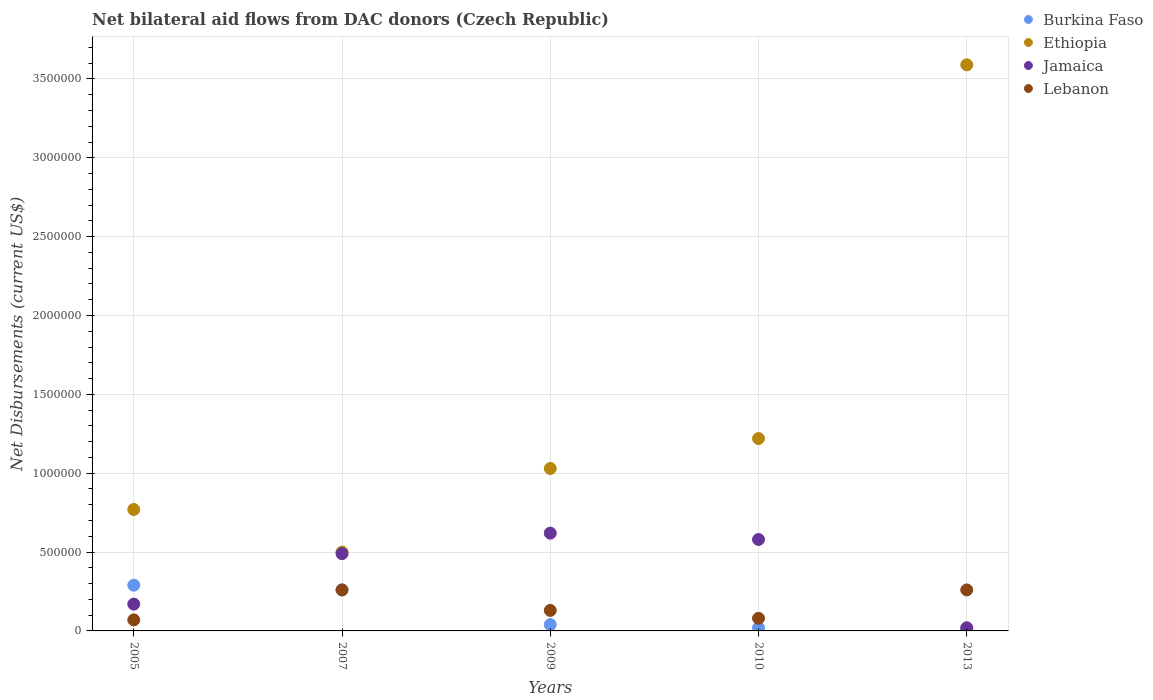What is the net bilateral aid flows in Ethiopia in 2010?
Offer a terse response. 1.22e+06. Across all years, what is the maximum net bilateral aid flows in Lebanon?
Give a very brief answer. 2.60e+05. In which year was the net bilateral aid flows in Lebanon maximum?
Keep it short and to the point. 2007. In which year was the net bilateral aid flows in Lebanon minimum?
Offer a very short reply. 2005. What is the total net bilateral aid flows in Ethiopia in the graph?
Your response must be concise. 7.11e+06. What is the difference between the net bilateral aid flows in Ethiopia in 2010 and that in 2013?
Give a very brief answer. -2.37e+06. What is the average net bilateral aid flows in Jamaica per year?
Keep it short and to the point. 3.76e+05. What is the ratio of the net bilateral aid flows in Jamaica in 2005 to that in 2009?
Your response must be concise. 0.27. Is the net bilateral aid flows in Lebanon in 2007 less than that in 2009?
Give a very brief answer. No. What is the difference between the highest and the second highest net bilateral aid flows in Lebanon?
Offer a terse response. 0. What is the difference between the highest and the lowest net bilateral aid flows in Burkina Faso?
Provide a short and direct response. 2.80e+05. In how many years, is the net bilateral aid flows in Burkina Faso greater than the average net bilateral aid flows in Burkina Faso taken over all years?
Offer a terse response. 2. Is the sum of the net bilateral aid flows in Jamaica in 2009 and 2010 greater than the maximum net bilateral aid flows in Ethiopia across all years?
Give a very brief answer. No. Is the net bilateral aid flows in Ethiopia strictly greater than the net bilateral aid flows in Burkina Faso over the years?
Keep it short and to the point. Yes. How many dotlines are there?
Provide a succinct answer. 4. Are the values on the major ticks of Y-axis written in scientific E-notation?
Provide a short and direct response. No. Does the graph contain any zero values?
Offer a terse response. No. What is the title of the graph?
Keep it short and to the point. Net bilateral aid flows from DAC donors (Czech Republic). Does "Greenland" appear as one of the legend labels in the graph?
Your response must be concise. No. What is the label or title of the Y-axis?
Ensure brevity in your answer.  Net Disbursements (current US$). What is the Net Disbursements (current US$) of Ethiopia in 2005?
Your response must be concise. 7.70e+05. What is the Net Disbursements (current US$) of Lebanon in 2005?
Your answer should be very brief. 7.00e+04. What is the Net Disbursements (current US$) of Burkina Faso in 2009?
Offer a terse response. 4.00e+04. What is the Net Disbursements (current US$) in Ethiopia in 2009?
Your response must be concise. 1.03e+06. What is the Net Disbursements (current US$) of Jamaica in 2009?
Provide a succinct answer. 6.20e+05. What is the Net Disbursements (current US$) in Lebanon in 2009?
Ensure brevity in your answer.  1.30e+05. What is the Net Disbursements (current US$) of Ethiopia in 2010?
Ensure brevity in your answer.  1.22e+06. What is the Net Disbursements (current US$) in Jamaica in 2010?
Ensure brevity in your answer.  5.80e+05. What is the Net Disbursements (current US$) of Lebanon in 2010?
Your answer should be compact. 8.00e+04. What is the Net Disbursements (current US$) of Ethiopia in 2013?
Your response must be concise. 3.59e+06. What is the Net Disbursements (current US$) of Jamaica in 2013?
Offer a very short reply. 2.00e+04. Across all years, what is the maximum Net Disbursements (current US$) of Ethiopia?
Make the answer very short. 3.59e+06. Across all years, what is the maximum Net Disbursements (current US$) of Jamaica?
Your answer should be compact. 6.20e+05. Across all years, what is the maximum Net Disbursements (current US$) in Lebanon?
Give a very brief answer. 2.60e+05. What is the total Net Disbursements (current US$) of Burkina Faso in the graph?
Your response must be concise. 6.20e+05. What is the total Net Disbursements (current US$) in Ethiopia in the graph?
Offer a terse response. 7.11e+06. What is the total Net Disbursements (current US$) in Jamaica in the graph?
Keep it short and to the point. 1.88e+06. What is the total Net Disbursements (current US$) of Lebanon in the graph?
Your response must be concise. 8.00e+05. What is the difference between the Net Disbursements (current US$) of Burkina Faso in 2005 and that in 2007?
Ensure brevity in your answer.  3.00e+04. What is the difference between the Net Disbursements (current US$) of Ethiopia in 2005 and that in 2007?
Ensure brevity in your answer.  2.70e+05. What is the difference between the Net Disbursements (current US$) of Jamaica in 2005 and that in 2007?
Ensure brevity in your answer.  -3.20e+05. What is the difference between the Net Disbursements (current US$) in Lebanon in 2005 and that in 2007?
Give a very brief answer. -1.90e+05. What is the difference between the Net Disbursements (current US$) in Burkina Faso in 2005 and that in 2009?
Your answer should be very brief. 2.50e+05. What is the difference between the Net Disbursements (current US$) of Jamaica in 2005 and that in 2009?
Give a very brief answer. -4.50e+05. What is the difference between the Net Disbursements (current US$) of Ethiopia in 2005 and that in 2010?
Your answer should be compact. -4.50e+05. What is the difference between the Net Disbursements (current US$) in Jamaica in 2005 and that in 2010?
Make the answer very short. -4.10e+05. What is the difference between the Net Disbursements (current US$) of Burkina Faso in 2005 and that in 2013?
Ensure brevity in your answer.  2.80e+05. What is the difference between the Net Disbursements (current US$) of Ethiopia in 2005 and that in 2013?
Your answer should be compact. -2.82e+06. What is the difference between the Net Disbursements (current US$) of Jamaica in 2005 and that in 2013?
Provide a succinct answer. 1.50e+05. What is the difference between the Net Disbursements (current US$) in Lebanon in 2005 and that in 2013?
Offer a very short reply. -1.90e+05. What is the difference between the Net Disbursements (current US$) in Ethiopia in 2007 and that in 2009?
Give a very brief answer. -5.30e+05. What is the difference between the Net Disbursements (current US$) in Lebanon in 2007 and that in 2009?
Offer a very short reply. 1.30e+05. What is the difference between the Net Disbursements (current US$) in Ethiopia in 2007 and that in 2010?
Provide a succinct answer. -7.20e+05. What is the difference between the Net Disbursements (current US$) of Jamaica in 2007 and that in 2010?
Give a very brief answer. -9.00e+04. What is the difference between the Net Disbursements (current US$) in Burkina Faso in 2007 and that in 2013?
Give a very brief answer. 2.50e+05. What is the difference between the Net Disbursements (current US$) of Ethiopia in 2007 and that in 2013?
Give a very brief answer. -3.09e+06. What is the difference between the Net Disbursements (current US$) of Lebanon in 2007 and that in 2013?
Keep it short and to the point. 0. What is the difference between the Net Disbursements (current US$) of Lebanon in 2009 and that in 2010?
Offer a terse response. 5.00e+04. What is the difference between the Net Disbursements (current US$) in Burkina Faso in 2009 and that in 2013?
Make the answer very short. 3.00e+04. What is the difference between the Net Disbursements (current US$) in Ethiopia in 2009 and that in 2013?
Your response must be concise. -2.56e+06. What is the difference between the Net Disbursements (current US$) of Jamaica in 2009 and that in 2013?
Offer a very short reply. 6.00e+05. What is the difference between the Net Disbursements (current US$) in Ethiopia in 2010 and that in 2013?
Ensure brevity in your answer.  -2.37e+06. What is the difference between the Net Disbursements (current US$) in Jamaica in 2010 and that in 2013?
Provide a short and direct response. 5.60e+05. What is the difference between the Net Disbursements (current US$) of Lebanon in 2010 and that in 2013?
Make the answer very short. -1.80e+05. What is the difference between the Net Disbursements (current US$) of Burkina Faso in 2005 and the Net Disbursements (current US$) of Jamaica in 2007?
Provide a short and direct response. -2.00e+05. What is the difference between the Net Disbursements (current US$) of Burkina Faso in 2005 and the Net Disbursements (current US$) of Lebanon in 2007?
Your answer should be compact. 3.00e+04. What is the difference between the Net Disbursements (current US$) in Ethiopia in 2005 and the Net Disbursements (current US$) in Jamaica in 2007?
Keep it short and to the point. 2.80e+05. What is the difference between the Net Disbursements (current US$) of Ethiopia in 2005 and the Net Disbursements (current US$) of Lebanon in 2007?
Ensure brevity in your answer.  5.10e+05. What is the difference between the Net Disbursements (current US$) of Jamaica in 2005 and the Net Disbursements (current US$) of Lebanon in 2007?
Provide a short and direct response. -9.00e+04. What is the difference between the Net Disbursements (current US$) in Burkina Faso in 2005 and the Net Disbursements (current US$) in Ethiopia in 2009?
Your answer should be compact. -7.40e+05. What is the difference between the Net Disbursements (current US$) of Burkina Faso in 2005 and the Net Disbursements (current US$) of Jamaica in 2009?
Keep it short and to the point. -3.30e+05. What is the difference between the Net Disbursements (current US$) of Ethiopia in 2005 and the Net Disbursements (current US$) of Jamaica in 2009?
Offer a very short reply. 1.50e+05. What is the difference between the Net Disbursements (current US$) in Ethiopia in 2005 and the Net Disbursements (current US$) in Lebanon in 2009?
Keep it short and to the point. 6.40e+05. What is the difference between the Net Disbursements (current US$) of Burkina Faso in 2005 and the Net Disbursements (current US$) of Ethiopia in 2010?
Offer a very short reply. -9.30e+05. What is the difference between the Net Disbursements (current US$) of Burkina Faso in 2005 and the Net Disbursements (current US$) of Lebanon in 2010?
Your response must be concise. 2.10e+05. What is the difference between the Net Disbursements (current US$) of Ethiopia in 2005 and the Net Disbursements (current US$) of Lebanon in 2010?
Provide a succinct answer. 6.90e+05. What is the difference between the Net Disbursements (current US$) in Jamaica in 2005 and the Net Disbursements (current US$) in Lebanon in 2010?
Ensure brevity in your answer.  9.00e+04. What is the difference between the Net Disbursements (current US$) in Burkina Faso in 2005 and the Net Disbursements (current US$) in Ethiopia in 2013?
Your response must be concise. -3.30e+06. What is the difference between the Net Disbursements (current US$) of Burkina Faso in 2005 and the Net Disbursements (current US$) of Jamaica in 2013?
Keep it short and to the point. 2.70e+05. What is the difference between the Net Disbursements (current US$) of Ethiopia in 2005 and the Net Disbursements (current US$) of Jamaica in 2013?
Provide a succinct answer. 7.50e+05. What is the difference between the Net Disbursements (current US$) in Ethiopia in 2005 and the Net Disbursements (current US$) in Lebanon in 2013?
Offer a terse response. 5.10e+05. What is the difference between the Net Disbursements (current US$) of Burkina Faso in 2007 and the Net Disbursements (current US$) of Ethiopia in 2009?
Make the answer very short. -7.70e+05. What is the difference between the Net Disbursements (current US$) of Burkina Faso in 2007 and the Net Disbursements (current US$) of Jamaica in 2009?
Provide a succinct answer. -3.60e+05. What is the difference between the Net Disbursements (current US$) of Ethiopia in 2007 and the Net Disbursements (current US$) of Lebanon in 2009?
Keep it short and to the point. 3.70e+05. What is the difference between the Net Disbursements (current US$) of Burkina Faso in 2007 and the Net Disbursements (current US$) of Ethiopia in 2010?
Offer a very short reply. -9.60e+05. What is the difference between the Net Disbursements (current US$) of Burkina Faso in 2007 and the Net Disbursements (current US$) of Jamaica in 2010?
Your answer should be compact. -3.20e+05. What is the difference between the Net Disbursements (current US$) in Burkina Faso in 2007 and the Net Disbursements (current US$) in Lebanon in 2010?
Your answer should be very brief. 1.80e+05. What is the difference between the Net Disbursements (current US$) in Ethiopia in 2007 and the Net Disbursements (current US$) in Lebanon in 2010?
Offer a very short reply. 4.20e+05. What is the difference between the Net Disbursements (current US$) of Jamaica in 2007 and the Net Disbursements (current US$) of Lebanon in 2010?
Your answer should be compact. 4.10e+05. What is the difference between the Net Disbursements (current US$) of Burkina Faso in 2007 and the Net Disbursements (current US$) of Ethiopia in 2013?
Offer a very short reply. -3.33e+06. What is the difference between the Net Disbursements (current US$) of Ethiopia in 2007 and the Net Disbursements (current US$) of Jamaica in 2013?
Offer a very short reply. 4.80e+05. What is the difference between the Net Disbursements (current US$) in Ethiopia in 2007 and the Net Disbursements (current US$) in Lebanon in 2013?
Give a very brief answer. 2.40e+05. What is the difference between the Net Disbursements (current US$) of Jamaica in 2007 and the Net Disbursements (current US$) of Lebanon in 2013?
Keep it short and to the point. 2.30e+05. What is the difference between the Net Disbursements (current US$) of Burkina Faso in 2009 and the Net Disbursements (current US$) of Ethiopia in 2010?
Give a very brief answer. -1.18e+06. What is the difference between the Net Disbursements (current US$) in Burkina Faso in 2009 and the Net Disbursements (current US$) in Jamaica in 2010?
Keep it short and to the point. -5.40e+05. What is the difference between the Net Disbursements (current US$) in Burkina Faso in 2009 and the Net Disbursements (current US$) in Lebanon in 2010?
Offer a terse response. -4.00e+04. What is the difference between the Net Disbursements (current US$) in Ethiopia in 2009 and the Net Disbursements (current US$) in Jamaica in 2010?
Ensure brevity in your answer.  4.50e+05. What is the difference between the Net Disbursements (current US$) of Ethiopia in 2009 and the Net Disbursements (current US$) of Lebanon in 2010?
Give a very brief answer. 9.50e+05. What is the difference between the Net Disbursements (current US$) in Jamaica in 2009 and the Net Disbursements (current US$) in Lebanon in 2010?
Make the answer very short. 5.40e+05. What is the difference between the Net Disbursements (current US$) of Burkina Faso in 2009 and the Net Disbursements (current US$) of Ethiopia in 2013?
Offer a terse response. -3.55e+06. What is the difference between the Net Disbursements (current US$) in Burkina Faso in 2009 and the Net Disbursements (current US$) in Jamaica in 2013?
Offer a very short reply. 2.00e+04. What is the difference between the Net Disbursements (current US$) of Burkina Faso in 2009 and the Net Disbursements (current US$) of Lebanon in 2013?
Provide a succinct answer. -2.20e+05. What is the difference between the Net Disbursements (current US$) in Ethiopia in 2009 and the Net Disbursements (current US$) in Jamaica in 2013?
Your answer should be compact. 1.01e+06. What is the difference between the Net Disbursements (current US$) of Ethiopia in 2009 and the Net Disbursements (current US$) of Lebanon in 2013?
Provide a short and direct response. 7.70e+05. What is the difference between the Net Disbursements (current US$) in Burkina Faso in 2010 and the Net Disbursements (current US$) in Ethiopia in 2013?
Keep it short and to the point. -3.57e+06. What is the difference between the Net Disbursements (current US$) of Burkina Faso in 2010 and the Net Disbursements (current US$) of Lebanon in 2013?
Your answer should be very brief. -2.40e+05. What is the difference between the Net Disbursements (current US$) in Ethiopia in 2010 and the Net Disbursements (current US$) in Jamaica in 2013?
Provide a short and direct response. 1.20e+06. What is the difference between the Net Disbursements (current US$) in Ethiopia in 2010 and the Net Disbursements (current US$) in Lebanon in 2013?
Provide a succinct answer. 9.60e+05. What is the average Net Disbursements (current US$) of Burkina Faso per year?
Keep it short and to the point. 1.24e+05. What is the average Net Disbursements (current US$) of Ethiopia per year?
Give a very brief answer. 1.42e+06. What is the average Net Disbursements (current US$) of Jamaica per year?
Ensure brevity in your answer.  3.76e+05. In the year 2005, what is the difference between the Net Disbursements (current US$) in Burkina Faso and Net Disbursements (current US$) in Ethiopia?
Ensure brevity in your answer.  -4.80e+05. In the year 2005, what is the difference between the Net Disbursements (current US$) in Burkina Faso and Net Disbursements (current US$) in Lebanon?
Provide a succinct answer. 2.20e+05. In the year 2005, what is the difference between the Net Disbursements (current US$) of Jamaica and Net Disbursements (current US$) of Lebanon?
Give a very brief answer. 1.00e+05. In the year 2007, what is the difference between the Net Disbursements (current US$) in Burkina Faso and Net Disbursements (current US$) in Ethiopia?
Keep it short and to the point. -2.40e+05. In the year 2007, what is the difference between the Net Disbursements (current US$) of Burkina Faso and Net Disbursements (current US$) of Jamaica?
Offer a very short reply. -2.30e+05. In the year 2007, what is the difference between the Net Disbursements (current US$) in Ethiopia and Net Disbursements (current US$) in Jamaica?
Your answer should be compact. 10000. In the year 2007, what is the difference between the Net Disbursements (current US$) in Ethiopia and Net Disbursements (current US$) in Lebanon?
Offer a terse response. 2.40e+05. In the year 2007, what is the difference between the Net Disbursements (current US$) in Jamaica and Net Disbursements (current US$) in Lebanon?
Your response must be concise. 2.30e+05. In the year 2009, what is the difference between the Net Disbursements (current US$) in Burkina Faso and Net Disbursements (current US$) in Ethiopia?
Offer a terse response. -9.90e+05. In the year 2009, what is the difference between the Net Disbursements (current US$) of Burkina Faso and Net Disbursements (current US$) of Jamaica?
Your response must be concise. -5.80e+05. In the year 2009, what is the difference between the Net Disbursements (current US$) of Burkina Faso and Net Disbursements (current US$) of Lebanon?
Make the answer very short. -9.00e+04. In the year 2009, what is the difference between the Net Disbursements (current US$) of Ethiopia and Net Disbursements (current US$) of Lebanon?
Your response must be concise. 9.00e+05. In the year 2009, what is the difference between the Net Disbursements (current US$) in Jamaica and Net Disbursements (current US$) in Lebanon?
Provide a short and direct response. 4.90e+05. In the year 2010, what is the difference between the Net Disbursements (current US$) of Burkina Faso and Net Disbursements (current US$) of Ethiopia?
Keep it short and to the point. -1.20e+06. In the year 2010, what is the difference between the Net Disbursements (current US$) in Burkina Faso and Net Disbursements (current US$) in Jamaica?
Ensure brevity in your answer.  -5.60e+05. In the year 2010, what is the difference between the Net Disbursements (current US$) in Burkina Faso and Net Disbursements (current US$) in Lebanon?
Ensure brevity in your answer.  -6.00e+04. In the year 2010, what is the difference between the Net Disbursements (current US$) in Ethiopia and Net Disbursements (current US$) in Jamaica?
Offer a terse response. 6.40e+05. In the year 2010, what is the difference between the Net Disbursements (current US$) in Ethiopia and Net Disbursements (current US$) in Lebanon?
Offer a terse response. 1.14e+06. In the year 2013, what is the difference between the Net Disbursements (current US$) of Burkina Faso and Net Disbursements (current US$) of Ethiopia?
Ensure brevity in your answer.  -3.58e+06. In the year 2013, what is the difference between the Net Disbursements (current US$) in Burkina Faso and Net Disbursements (current US$) in Lebanon?
Your response must be concise. -2.50e+05. In the year 2013, what is the difference between the Net Disbursements (current US$) of Ethiopia and Net Disbursements (current US$) of Jamaica?
Make the answer very short. 3.57e+06. In the year 2013, what is the difference between the Net Disbursements (current US$) of Ethiopia and Net Disbursements (current US$) of Lebanon?
Offer a terse response. 3.33e+06. In the year 2013, what is the difference between the Net Disbursements (current US$) in Jamaica and Net Disbursements (current US$) in Lebanon?
Make the answer very short. -2.40e+05. What is the ratio of the Net Disbursements (current US$) in Burkina Faso in 2005 to that in 2007?
Provide a succinct answer. 1.12. What is the ratio of the Net Disbursements (current US$) in Ethiopia in 2005 to that in 2007?
Your response must be concise. 1.54. What is the ratio of the Net Disbursements (current US$) of Jamaica in 2005 to that in 2007?
Give a very brief answer. 0.35. What is the ratio of the Net Disbursements (current US$) of Lebanon in 2005 to that in 2007?
Give a very brief answer. 0.27. What is the ratio of the Net Disbursements (current US$) of Burkina Faso in 2005 to that in 2009?
Make the answer very short. 7.25. What is the ratio of the Net Disbursements (current US$) in Ethiopia in 2005 to that in 2009?
Offer a very short reply. 0.75. What is the ratio of the Net Disbursements (current US$) in Jamaica in 2005 to that in 2009?
Provide a succinct answer. 0.27. What is the ratio of the Net Disbursements (current US$) of Lebanon in 2005 to that in 2009?
Offer a very short reply. 0.54. What is the ratio of the Net Disbursements (current US$) of Ethiopia in 2005 to that in 2010?
Make the answer very short. 0.63. What is the ratio of the Net Disbursements (current US$) of Jamaica in 2005 to that in 2010?
Offer a terse response. 0.29. What is the ratio of the Net Disbursements (current US$) of Lebanon in 2005 to that in 2010?
Provide a succinct answer. 0.88. What is the ratio of the Net Disbursements (current US$) of Ethiopia in 2005 to that in 2013?
Keep it short and to the point. 0.21. What is the ratio of the Net Disbursements (current US$) of Lebanon in 2005 to that in 2013?
Provide a short and direct response. 0.27. What is the ratio of the Net Disbursements (current US$) of Burkina Faso in 2007 to that in 2009?
Ensure brevity in your answer.  6.5. What is the ratio of the Net Disbursements (current US$) of Ethiopia in 2007 to that in 2009?
Offer a very short reply. 0.49. What is the ratio of the Net Disbursements (current US$) of Jamaica in 2007 to that in 2009?
Your response must be concise. 0.79. What is the ratio of the Net Disbursements (current US$) in Lebanon in 2007 to that in 2009?
Your response must be concise. 2. What is the ratio of the Net Disbursements (current US$) of Ethiopia in 2007 to that in 2010?
Your answer should be compact. 0.41. What is the ratio of the Net Disbursements (current US$) of Jamaica in 2007 to that in 2010?
Offer a terse response. 0.84. What is the ratio of the Net Disbursements (current US$) of Burkina Faso in 2007 to that in 2013?
Your answer should be very brief. 26. What is the ratio of the Net Disbursements (current US$) in Ethiopia in 2007 to that in 2013?
Provide a short and direct response. 0.14. What is the ratio of the Net Disbursements (current US$) in Jamaica in 2007 to that in 2013?
Your response must be concise. 24.5. What is the ratio of the Net Disbursements (current US$) in Burkina Faso in 2009 to that in 2010?
Provide a short and direct response. 2. What is the ratio of the Net Disbursements (current US$) of Ethiopia in 2009 to that in 2010?
Provide a short and direct response. 0.84. What is the ratio of the Net Disbursements (current US$) in Jamaica in 2009 to that in 2010?
Make the answer very short. 1.07. What is the ratio of the Net Disbursements (current US$) in Lebanon in 2009 to that in 2010?
Make the answer very short. 1.62. What is the ratio of the Net Disbursements (current US$) of Burkina Faso in 2009 to that in 2013?
Offer a very short reply. 4. What is the ratio of the Net Disbursements (current US$) in Ethiopia in 2009 to that in 2013?
Offer a terse response. 0.29. What is the ratio of the Net Disbursements (current US$) in Lebanon in 2009 to that in 2013?
Your answer should be compact. 0.5. What is the ratio of the Net Disbursements (current US$) in Ethiopia in 2010 to that in 2013?
Offer a very short reply. 0.34. What is the ratio of the Net Disbursements (current US$) in Lebanon in 2010 to that in 2013?
Give a very brief answer. 0.31. What is the difference between the highest and the second highest Net Disbursements (current US$) of Ethiopia?
Give a very brief answer. 2.37e+06. What is the difference between the highest and the second highest Net Disbursements (current US$) of Jamaica?
Provide a short and direct response. 4.00e+04. What is the difference between the highest and the second highest Net Disbursements (current US$) of Lebanon?
Offer a very short reply. 0. What is the difference between the highest and the lowest Net Disbursements (current US$) in Ethiopia?
Offer a very short reply. 3.09e+06. What is the difference between the highest and the lowest Net Disbursements (current US$) in Jamaica?
Give a very brief answer. 6.00e+05. 